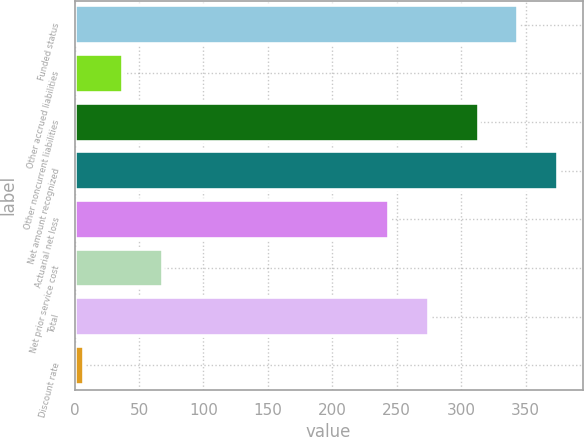Convert chart to OTSL. <chart><loc_0><loc_0><loc_500><loc_500><bar_chart><fcel>Funded status<fcel>Other accrued liabilities<fcel>Other noncurrent liabilities<fcel>Net amount recognized<fcel>Actuarial net loss<fcel>Net prior service cost<fcel>Total<fcel>Discount rate<nl><fcel>344.53<fcel>37.93<fcel>313.5<fcel>375.56<fcel>244.1<fcel>68.96<fcel>275.13<fcel>6.9<nl></chart> 